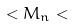Convert formula to latex. <formula><loc_0><loc_0><loc_500><loc_500>< M _ { n } <</formula> 